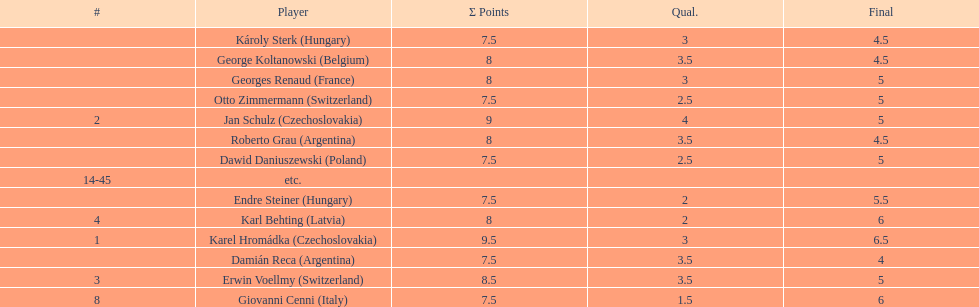How many players had final scores higher than 5? 4. 